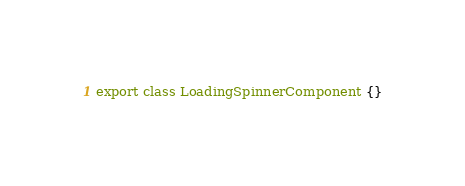Convert code to text. <code><loc_0><loc_0><loc_500><loc_500><_TypeScript_>export class LoadingSpinnerComponent {}
</code> 